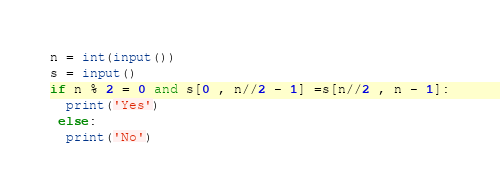<code> <loc_0><loc_0><loc_500><loc_500><_Python_>n = int(input())
s = input()
if n % 2 = 0 and s[0 , n//2 - 1] =s[n//2 , n - 1]:
  print('Yes')
 else:
  print('No')
</code> 